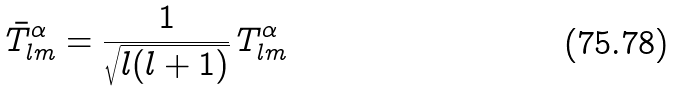Convert formula to latex. <formula><loc_0><loc_0><loc_500><loc_500>\bar { T } ^ { \alpha } _ { l m } = \frac { 1 } { \sqrt { l ( l + 1 ) } } \, T ^ { \alpha } _ { l m }</formula> 